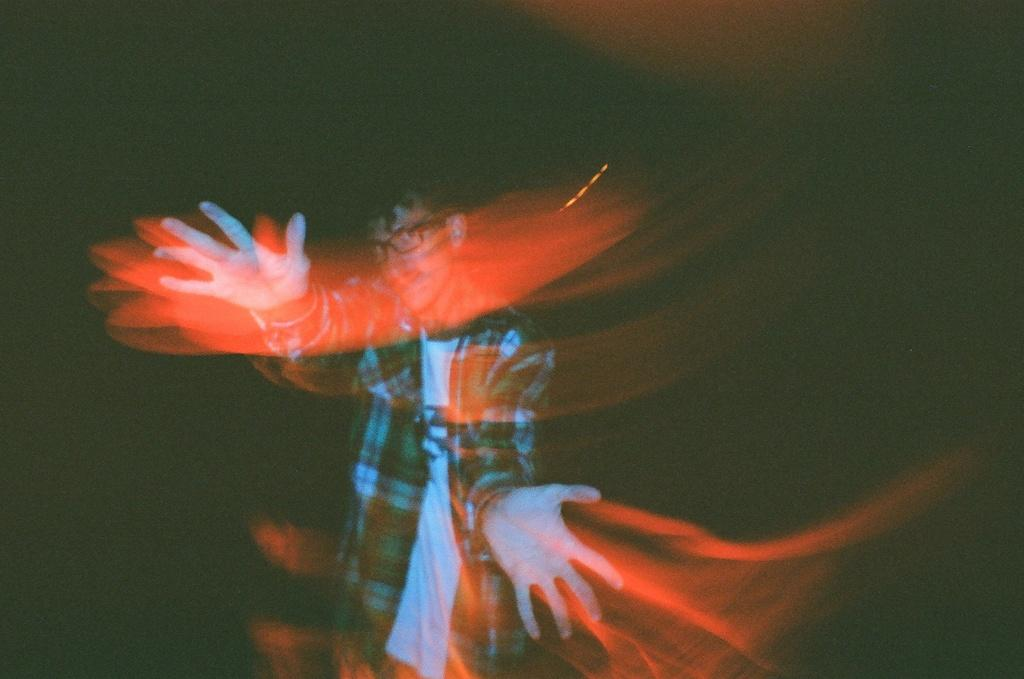What is the main subject of the image? There is a person standing in the image. Can you describe the person's clothing? The person is wearing a dress with different colors. What colors are present in the background of the image? The background of the image has black and red colors. Is there a snail crawling on the person's dress in the image? There is no snail present in the image. How does the rain affect the person's appearance in the image? There is no rain present in the image, so it does not affect the person's appearance. 